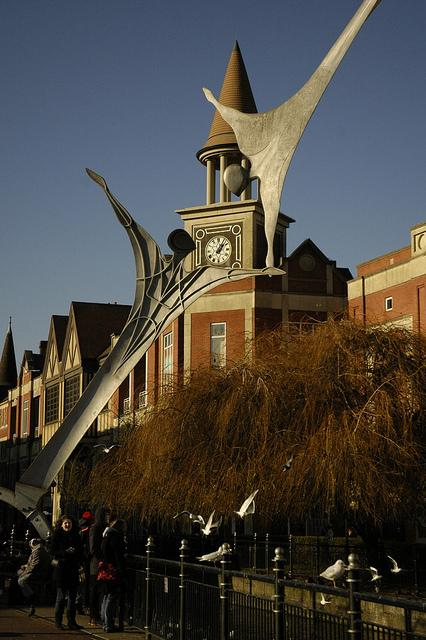The human-shaped decorations are made of what material? metal 